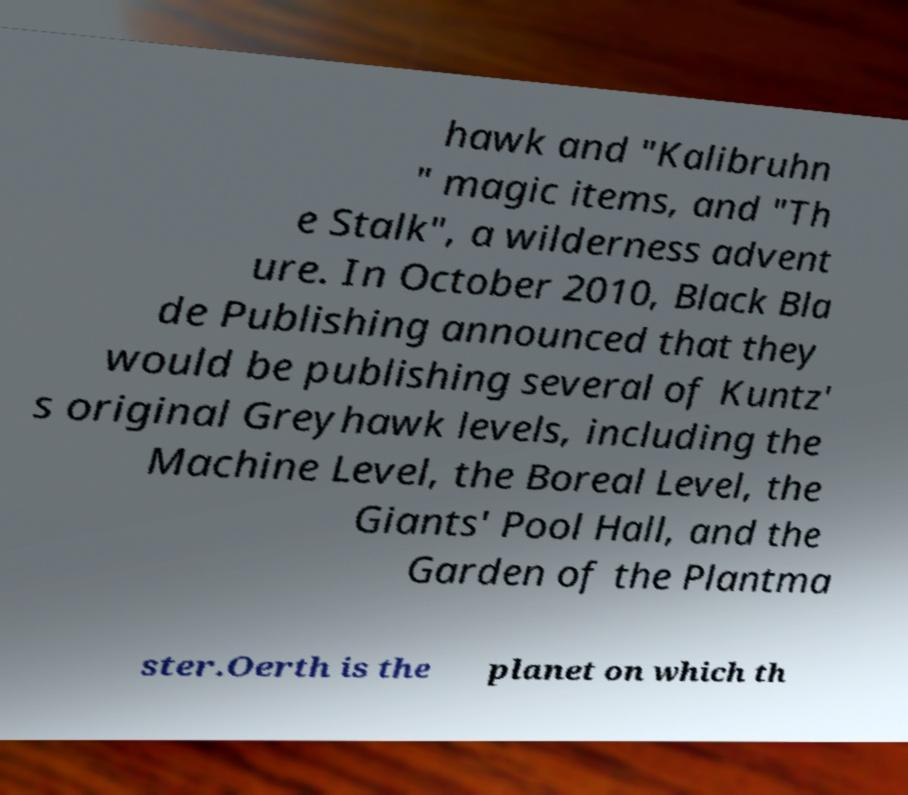Can you accurately transcribe the text from the provided image for me? hawk and "Kalibruhn " magic items, and "Th e Stalk", a wilderness advent ure. In October 2010, Black Bla de Publishing announced that they would be publishing several of Kuntz' s original Greyhawk levels, including the Machine Level, the Boreal Level, the Giants' Pool Hall, and the Garden of the Plantma ster.Oerth is the planet on which th 